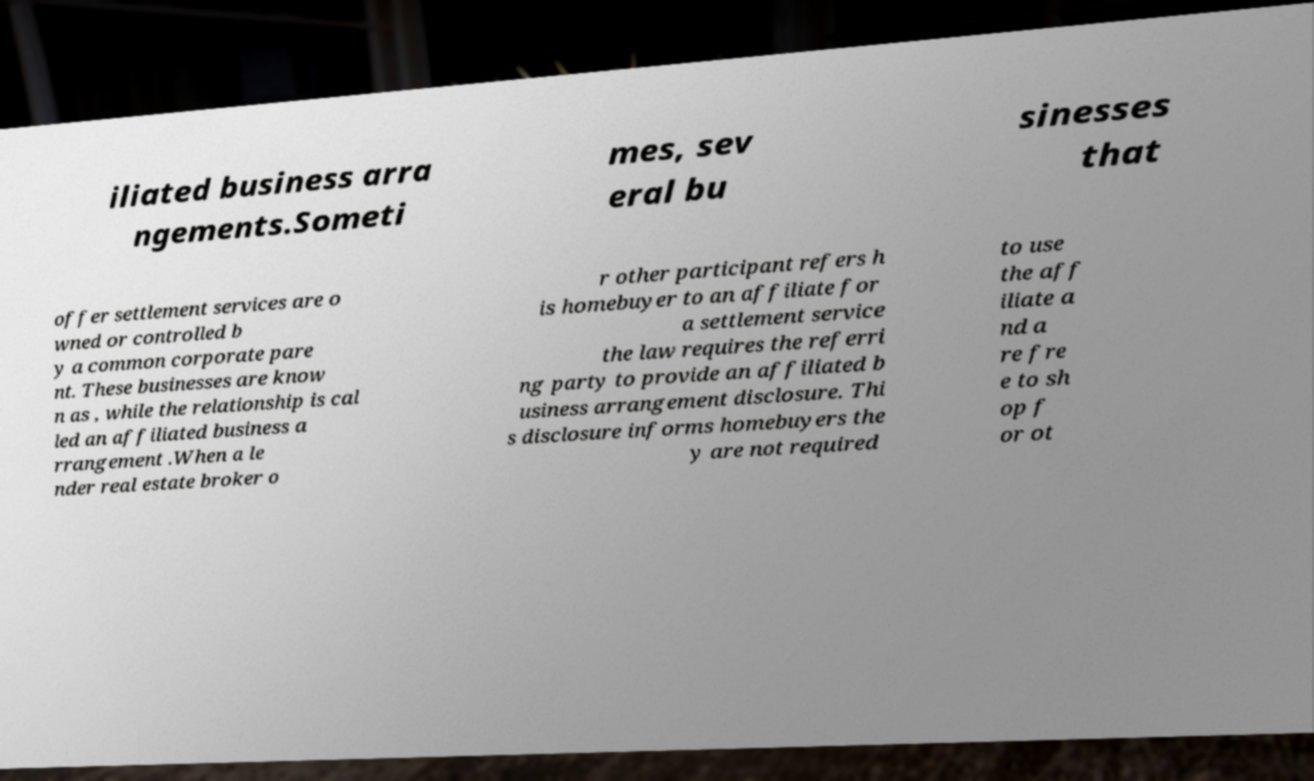Please read and relay the text visible in this image. What does it say? iliated business arra ngements.Someti mes, sev eral bu sinesses that offer settlement services are o wned or controlled b y a common corporate pare nt. These businesses are know n as , while the relationship is cal led an affiliated business a rrangement .When a le nder real estate broker o r other participant refers h is homebuyer to an affiliate for a settlement service the law requires the referri ng party to provide an affiliated b usiness arrangement disclosure. Thi s disclosure informs homebuyers the y are not required to use the aff iliate a nd a re fre e to sh op f or ot 